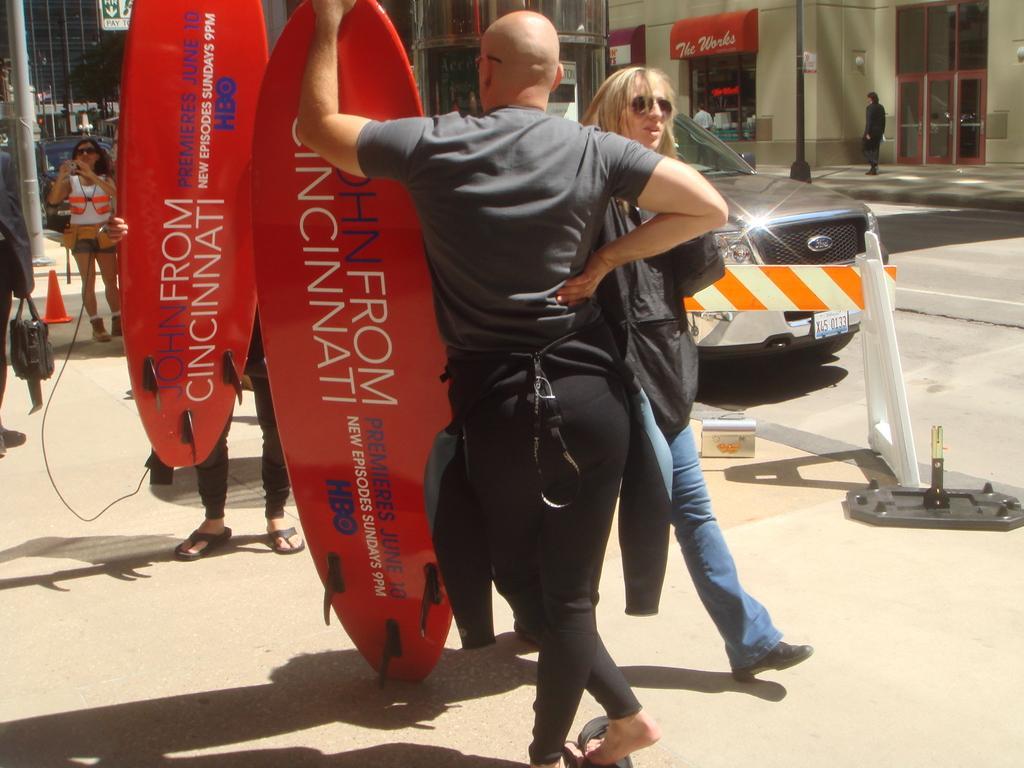In one or two sentences, can you explain what this image depicts? In this picture we can see some persons walking and some are standing and in front of them they are carrying surf boards and beside to them they have road and on road we can see vehicle and in background we can see sign board, pole, doors, shops. 